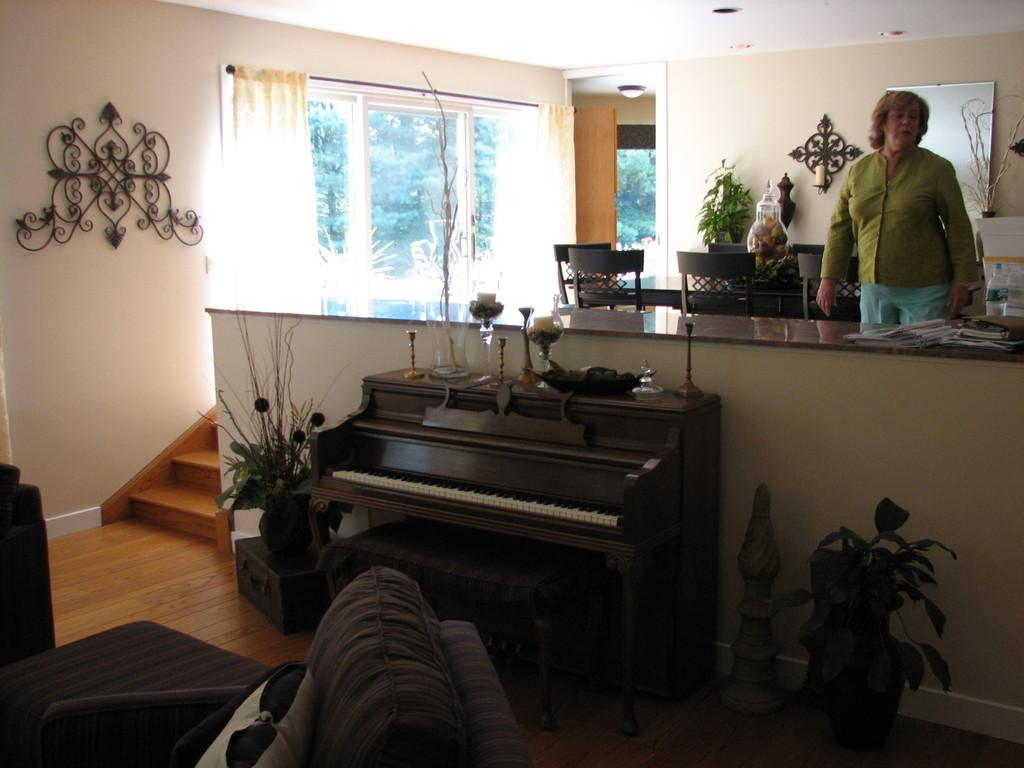What is the main object in the image? There is a piano in the image. Where is the woman located in the image? The woman is standing on the top right of the image. What is the woman doing in the image? The woman is looking at something. What type of furniture can be seen in the image? There is a dining table and a sofa in the image. What type of dirt can be seen on the stage in the image? There is no stage or dirt present in the image. How many cherries are on the piano in the image? There are no cherries on the piano in the image. 